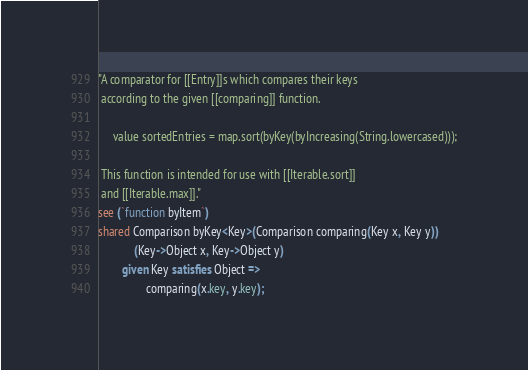<code> <loc_0><loc_0><loc_500><loc_500><_Ceylon_>"A comparator for [[Entry]]s which compares their keys 
 according to the given [[comparing]] function.
 
     value sortedEntries = map.sort(byKey(byIncreasing(String.lowercased)));
 
 This function is intended for use with [[Iterable.sort]]
 and [[Iterable.max]]."
see (`function byItem`)
shared Comparison byKey<Key>(Comparison comparing(Key x, Key y))
            (Key->Object x, Key->Object y) 
        given Key satisfies Object =>
                comparing(x.key, y.key);</code> 